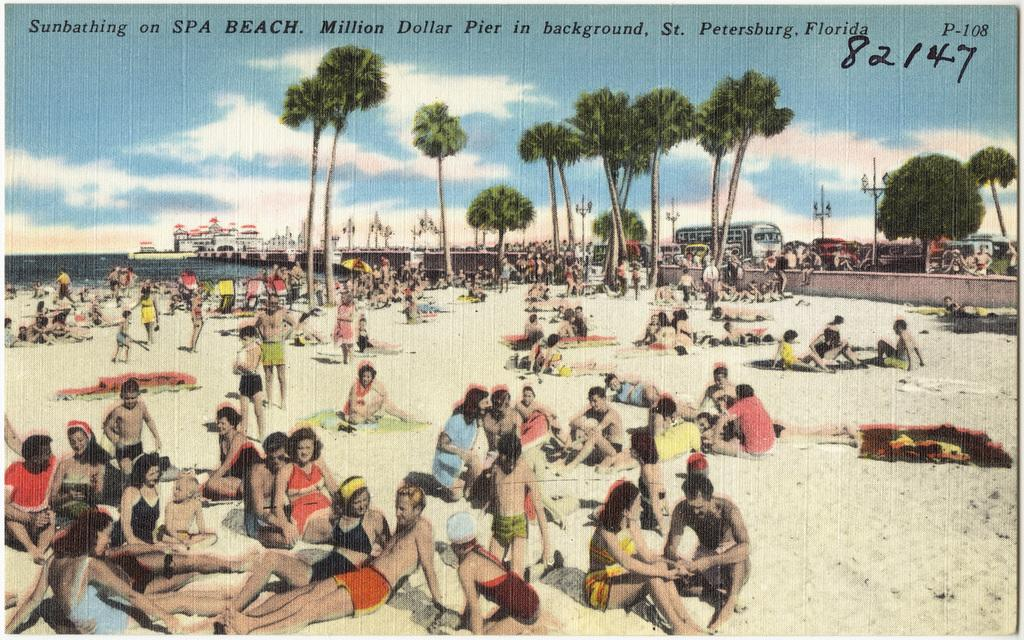What is the main subject of the image? The main subject of the image is a huge crowd on the sand in front of the beach. What can be seen on the right side of the image? There are many trees and vehicles on the right side of the image. Is there any structure visible in the distance? Yes, there is a building visible in the distance. What type of blade can be seen cutting through the sand in the image? There is no blade cutting through the sand in the image. What kind of breakfast is being served to the fairies in the image? There are no fairies or breakfast present in the image. 